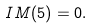Convert formula to latex. <formula><loc_0><loc_0><loc_500><loc_500>I M ( 5 ) = 0 .</formula> 